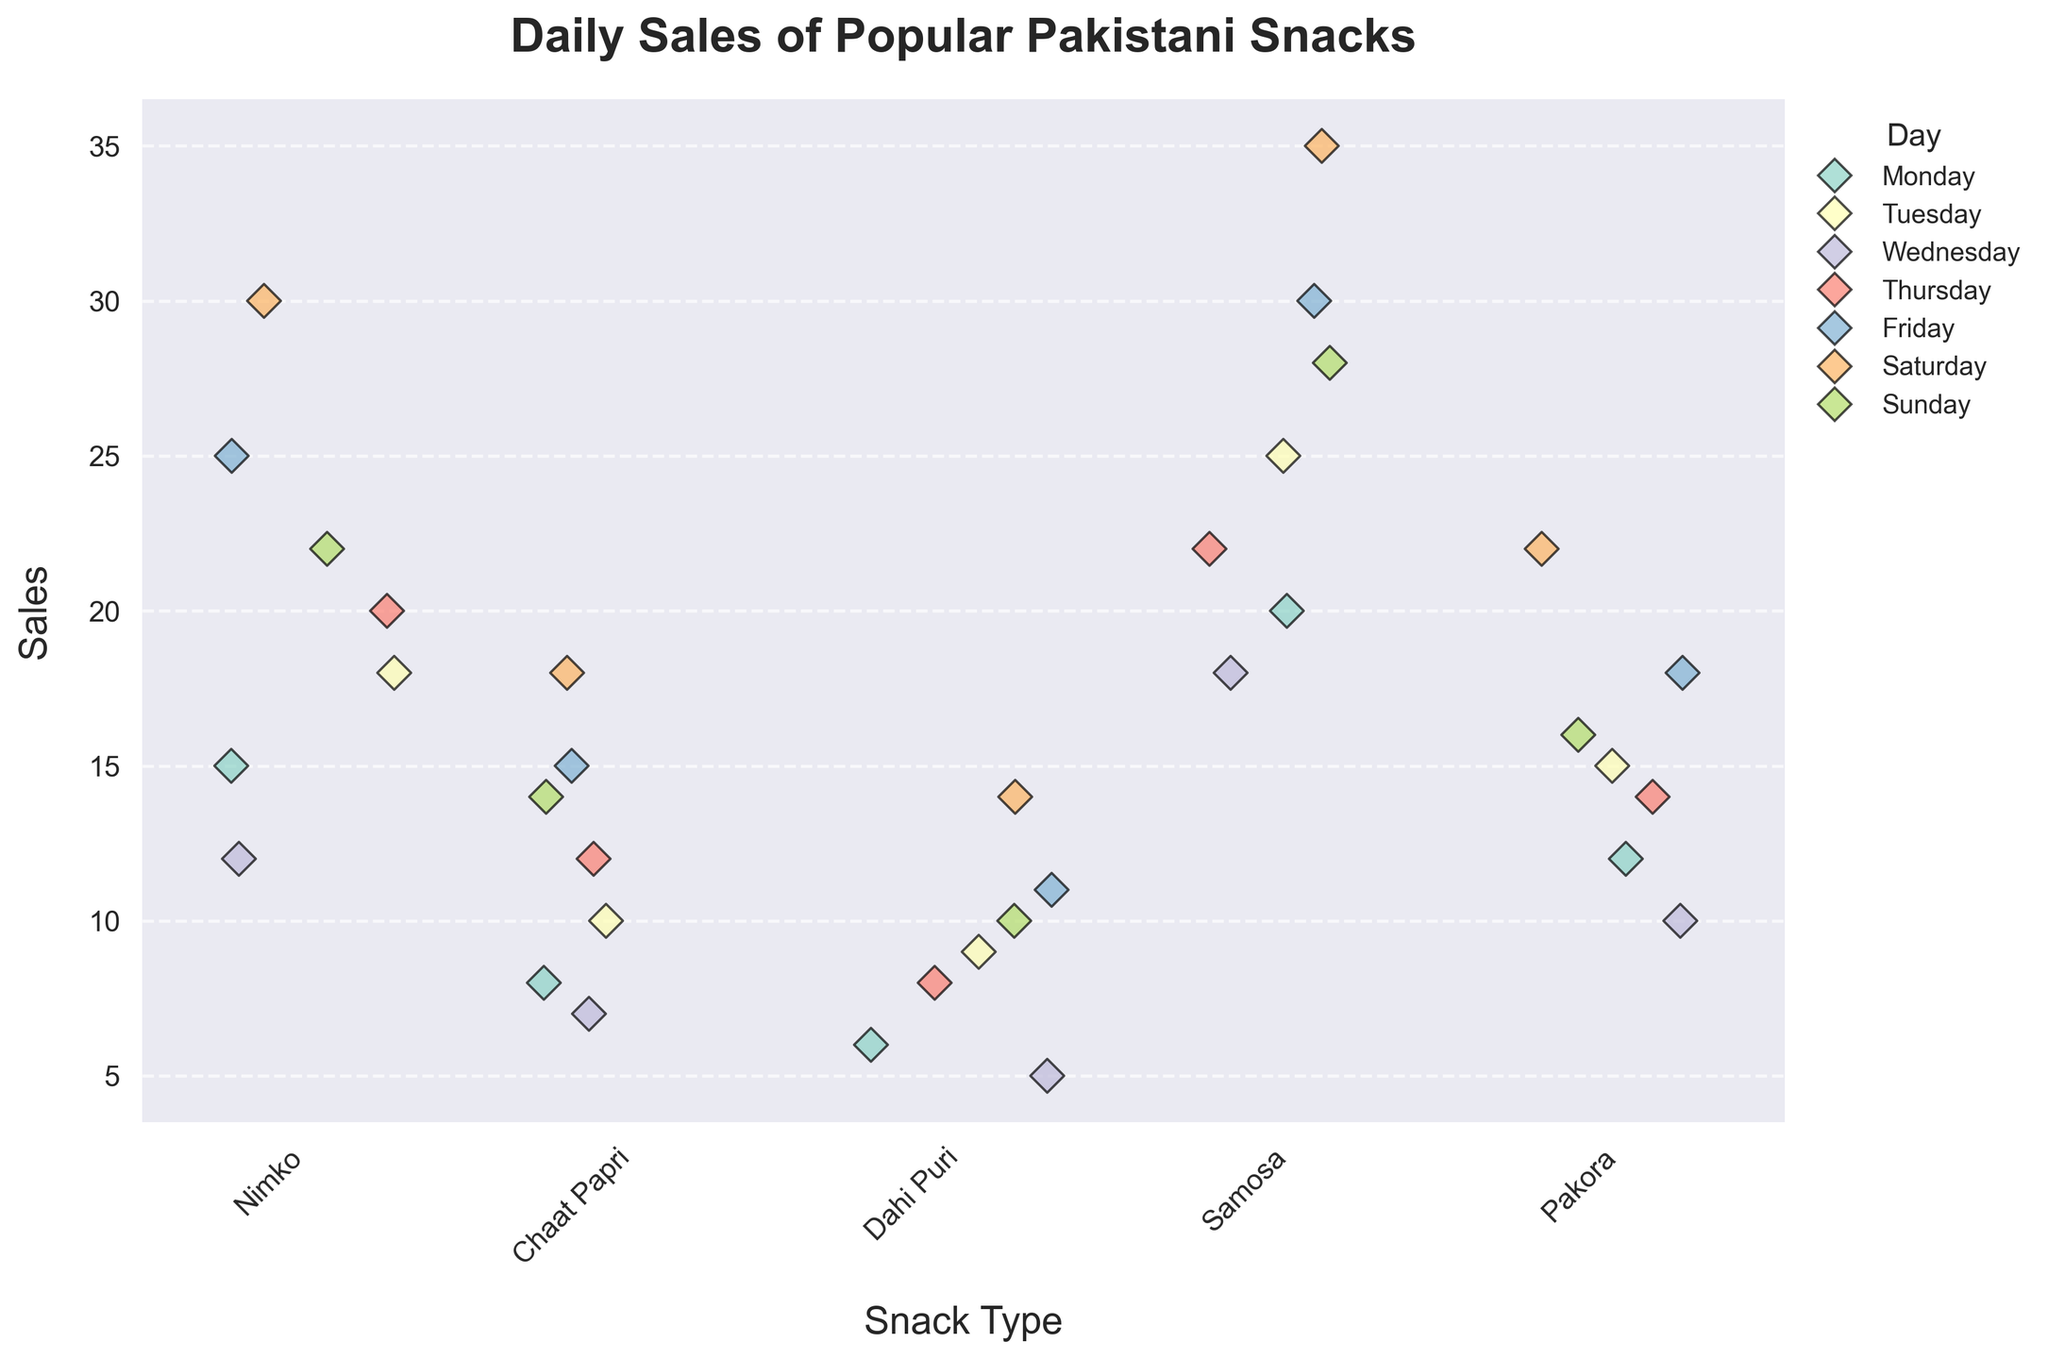What is the title of the strip plot? The title is located at the top of the plot; it is usually written in a larger and bolder font to make it clear.
Answer: Daily Sales of Popular Pakistani Snacks Which snack type has the highest individual sales value? The highest sales value in the plot is represented by the tallest marker, which represents Samosa with 35 sales on Saturday.
Answer: Samosa What are the sales of Nimko on Friday? Look for the color associated with Friday in the legend and find the corresponding colored marker on the "Nimko" strip.
Answer: 25 Which snack had the least sales on Wednesday? Check the color for Wednesday in the legend and find the lowest position marker in each strip for that day. The lowest marker on Wednesday is for Dahi Puri (5 sales).
Answer: Dahi Puri How many different days are represented in the strip plot? By counting the number of unique colors in the legend, we can determine the number of different days.
Answer: 7 What is the range of sales for Pakora throughout the week? Find the minimum and maximum sales values of Pakora markers in the strip plot (10 on Wednesday and 22 on Saturday) and calculate the range.
Answer: 12 Which snack shows the most consistent sales across all days? Consistency can be evaluated by looking at the spread of the markers; Chaat Papri's sales values are closer together compared to other snacks.
Answer: Chaat Papri On which day did Dahi Puri see its highest sales? Look for the highest marker for Dahi Puri strip and check its color, which corresponds to the day in the legend.
Answer: Saturday Compare the average sales of Samosa and Pakora. Which one has higher average sales? Calculate the average sales for Samosa and Pakora by summing up all sales for each and dividing by 7. Samosa: (20+25+18+22+30+35+28)/7 = 25.43, Pakora: (12+15+10+14+18+22+16)/7 = 15.29.
Answer: Samosa Considering the strip plot, which day seems to generally have higher sales for most snacks? Check the positions of the markers for each day across all snacks, focusing on the markers that are generally higher in the plot. The day appears to be Saturday.
Answer: Saturday 